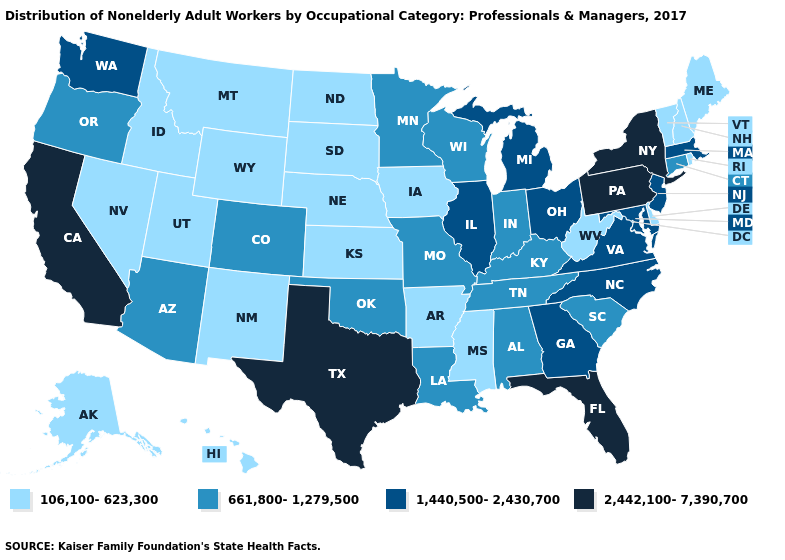Among the states that border Delaware , which have the highest value?
Quick response, please. Pennsylvania. Which states have the lowest value in the Northeast?
Quick response, please. Maine, New Hampshire, Rhode Island, Vermont. Among the states that border Virginia , which have the highest value?
Quick response, please. Maryland, North Carolina. Does Texas have the lowest value in the South?
Be succinct. No. What is the highest value in the USA?
Short answer required. 2,442,100-7,390,700. Among the states that border Nebraska , does Colorado have the highest value?
Concise answer only. Yes. What is the value of Nevada?
Quick response, please. 106,100-623,300. Which states have the highest value in the USA?
Write a very short answer. California, Florida, New York, Pennsylvania, Texas. What is the value of Minnesota?
Concise answer only. 661,800-1,279,500. Does the first symbol in the legend represent the smallest category?
Answer briefly. Yes. What is the value of Washington?
Keep it brief. 1,440,500-2,430,700. What is the value of Colorado?
Quick response, please. 661,800-1,279,500. Name the states that have a value in the range 1,440,500-2,430,700?
Write a very short answer. Georgia, Illinois, Maryland, Massachusetts, Michigan, New Jersey, North Carolina, Ohio, Virginia, Washington. What is the lowest value in the USA?
Keep it brief. 106,100-623,300. Which states hav the highest value in the MidWest?
Be succinct. Illinois, Michigan, Ohio. 